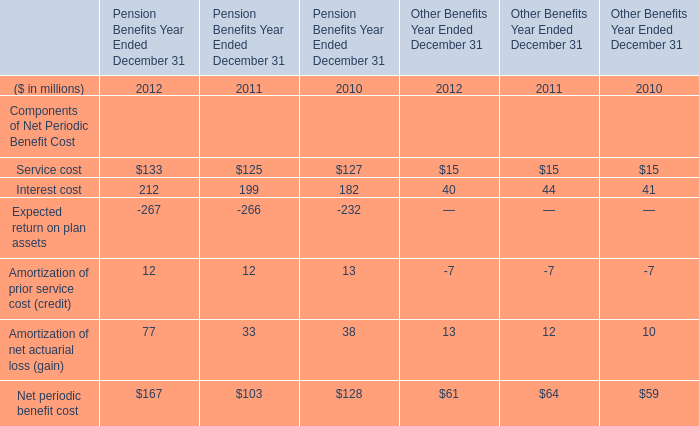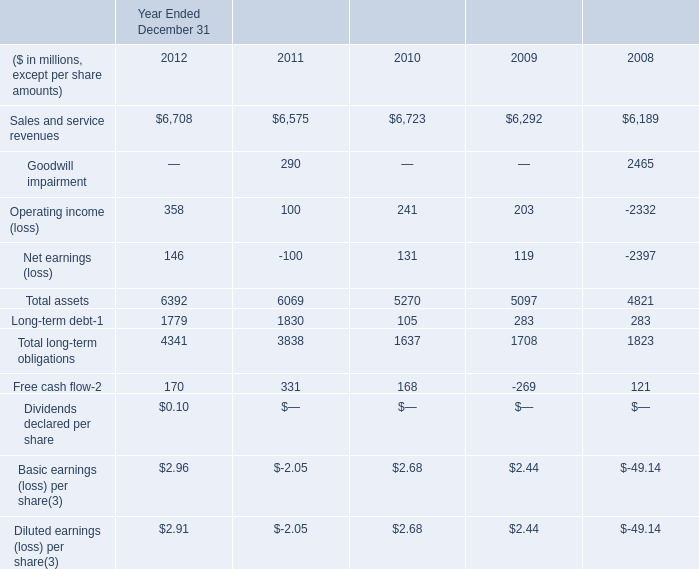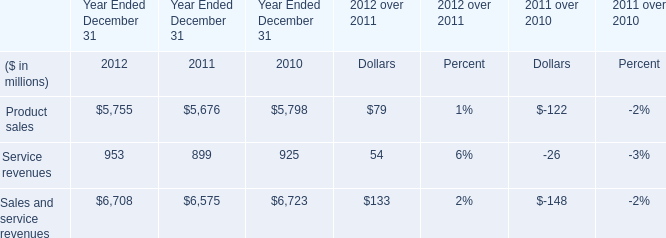What is the average amount of Goodwill impairment of Year Ended December 31 2008, and Product sales of Year Ended December 31 2012 ? 
Computations: ((2465.0 + 5755.0) / 2)
Answer: 4110.0. 